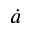<formula> <loc_0><loc_0><loc_500><loc_500>\dot { a }</formula> 